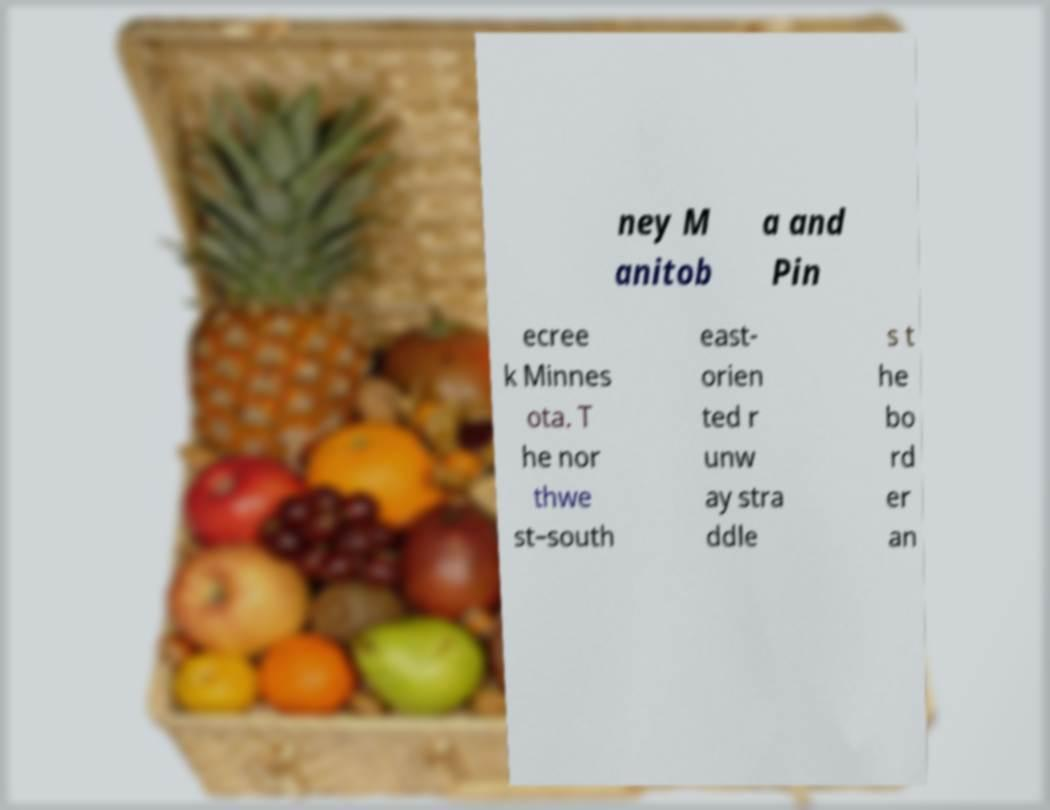Please identify and transcribe the text found in this image. ney M anitob a and Pin ecree k Minnes ota. T he nor thwe st–south east- orien ted r unw ay stra ddle s t he bo rd er an 